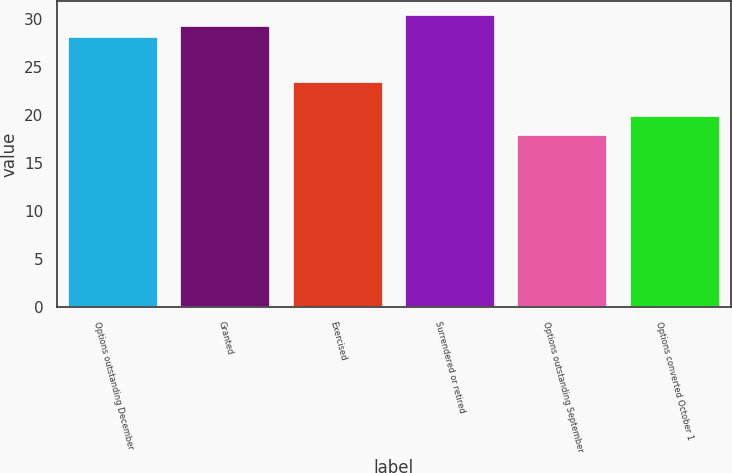Convert chart to OTSL. <chart><loc_0><loc_0><loc_500><loc_500><bar_chart><fcel>Options outstanding December<fcel>Granted<fcel>Exercised<fcel>Surrendered or retired<fcel>Options outstanding September<fcel>Options converted October 1<nl><fcel>28.12<fcel>29.26<fcel>23.44<fcel>30.4<fcel>17.99<fcel>19.94<nl></chart> 